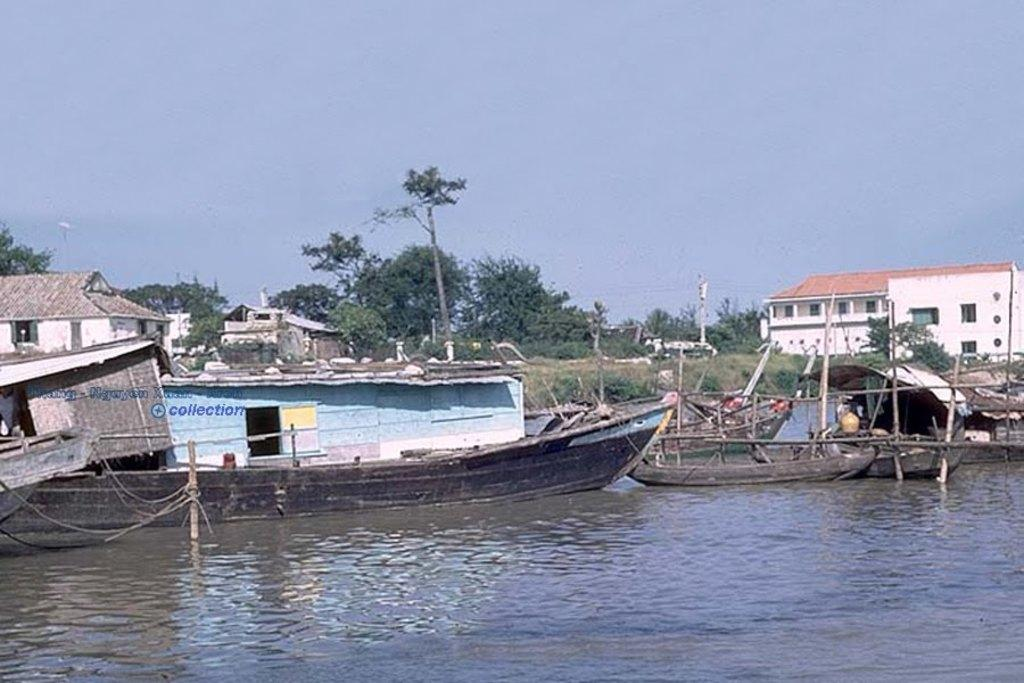What type of vehicles can be seen on the water in the image? There are boats on the water in the image. What structures are visible in the background? There are houses visible in the background. What type of vegetation is visible in the background? There are trees visible in the background. What is visible above the houses and trees? The sky is visible in the background. What type of quartz can be seen in the image? There is no quartz present in the image. How many knees are visible in the image? There are no knees visible in the image. 